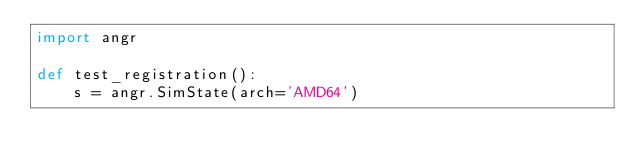<code> <loc_0><loc_0><loc_500><loc_500><_Python_>import angr

def test_registration():
    s = angr.SimState(arch='AMD64')
</code> 